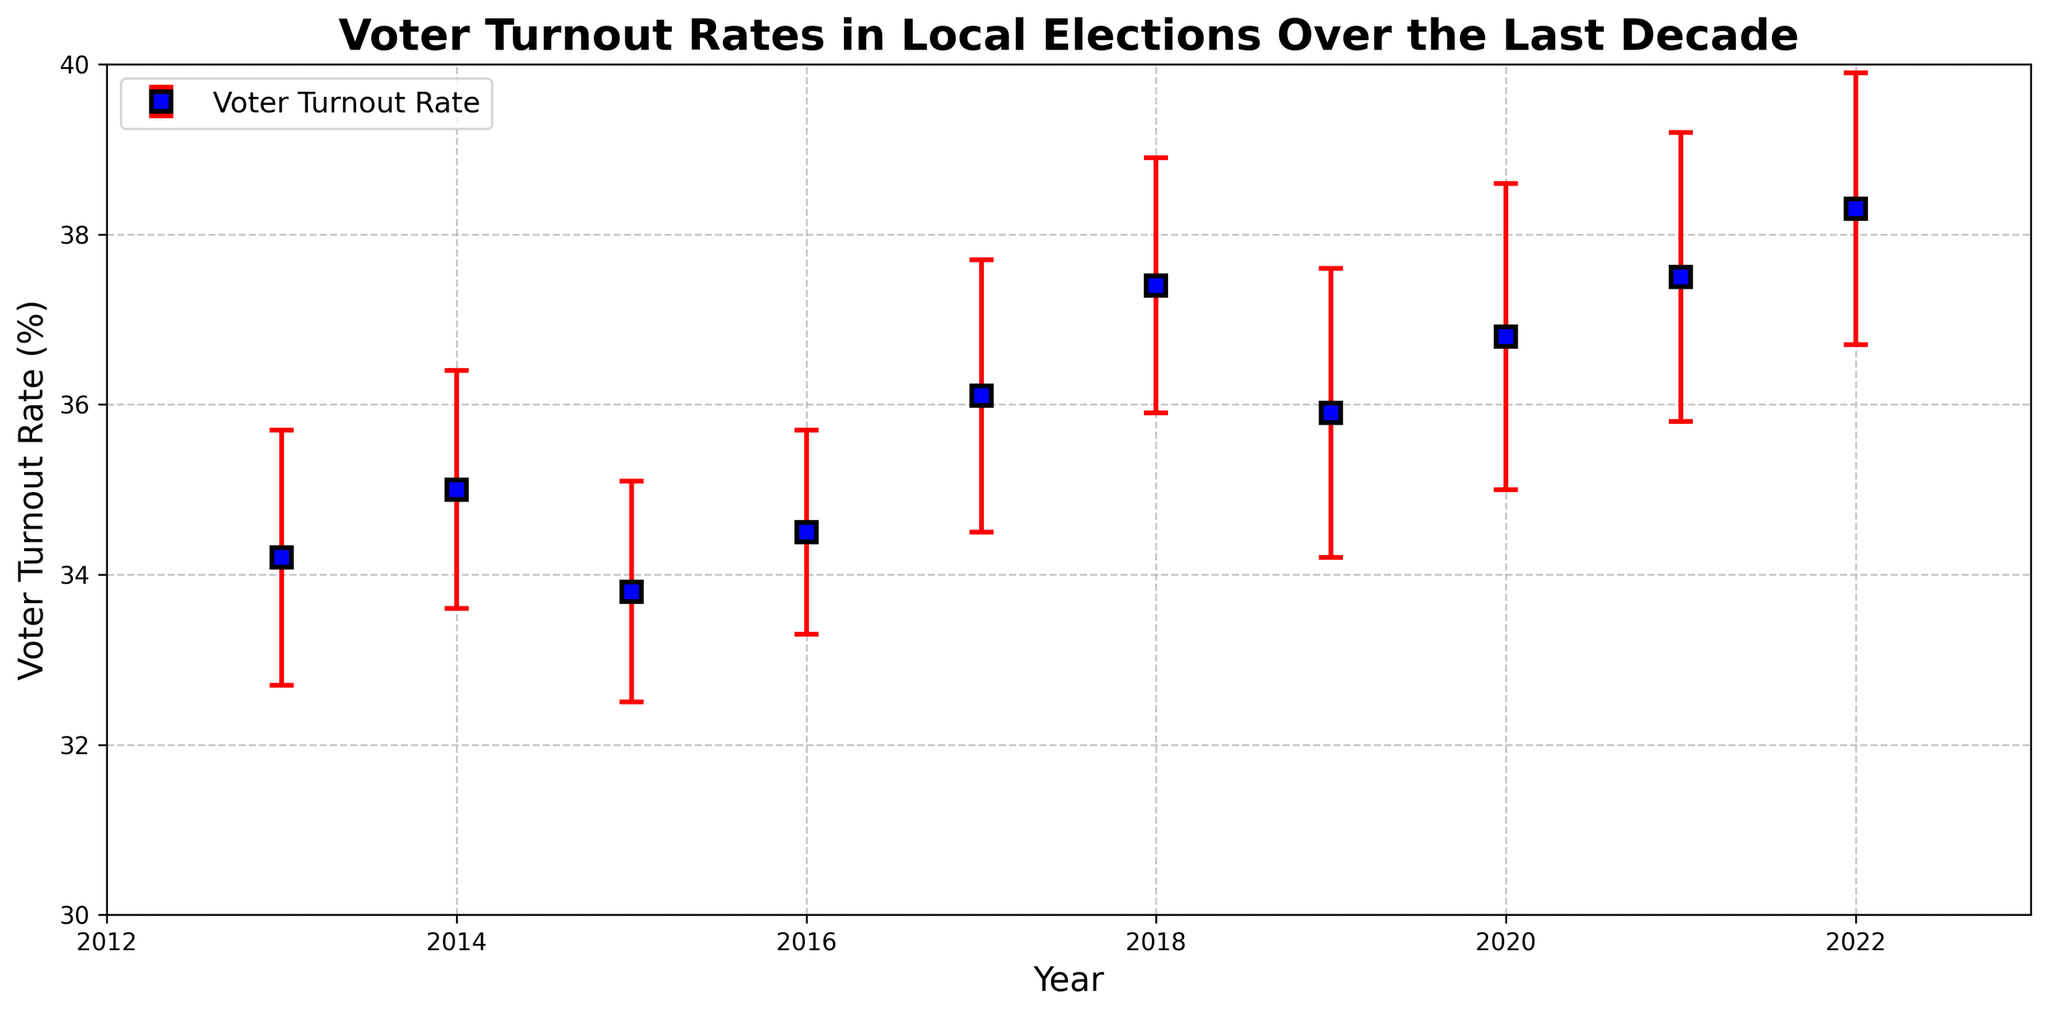What was the voter turnout rate in 2018? Look at the data point marked for the year 2018 on the x-axis and read the corresponding voter turnout rate on the y-axis.
Answer: 37.4% Which year had the highest voter turnout rate? Scan through the turnout rates and identify the highest value, then locate the corresponding year on the x-axis.
Answer: 2022 What is the difference in voter turnout rate between 2015 and 2022? Identify the voter turnout rates for 2015 and 2022, then subtract the 2015 rate from the 2022 rate (38.3% - 33.8%).
Answer: 4.5% Explain the trend in voter turnout rates from 2017 to 2020. Review the data points from 2017 to 2020, and observe the changes in the voter turnout rates. The rates increased from 36.1% in 2017 to 37.5% in 2018 followed by a slight decrease to 35.9% in 2019 and then an increase to 36.8% in 2020.
Answer: Increasing trend with a dip in 2019 Is the voter turnout rate in 2017 within the margin of error of the rate in 2018? Check the voter turnout rate and margin of error for both 2017 and 2018. Calculate the range for 2017 (34.5% to 37.7%) and for 2018 (35.9% to 38.9%) and check for overlap.
Answer: Yes What is the median voter turnout rate from 2013 to 2022? Order the turnout rates and find the middle value. Ordered rates: [33.8, 34.2, 34.5, 35.0, 35.9, 36.1, 36.8, 37.4, 37.5, 38.3]. The median is the average of the 5th and 6th values, (35.9 + 36.1) / 2.
Answer: 36.0% Did the voter turnout rate ever decrease from one year to the next? Compare the voter turnout rates of consecutive years and identify if there was any decrease. The rate decreased from 2014 (35.0) to 2015 (33.8) and from 2018 (37.4) to 2019 (35.9).
Answer: Yes What was the average voter turnout rate over the 10 years? Sum all voter turnout rates and divide by the number of years: (34.2 + 35.0 + 33.8 + 34.5 + 36.1 + 37.4 + 35.9 + 36.8 + 37.5 + 38.3) / 10.
Answer: 35.95% In which year was the margin of error the highest? Locate the year associated with the highest margin of error by comparing the margin values.
Answer: 2020 Is there any year where the voter turnout rate is significantly different if considering the margin of error? Compare the voter turnout rates and their margins of error. Since the margins of error are relatively close, determine if there’s a non-overlapping confidence interval. No such case since all rates’ ranges overlap.
Answer: No 